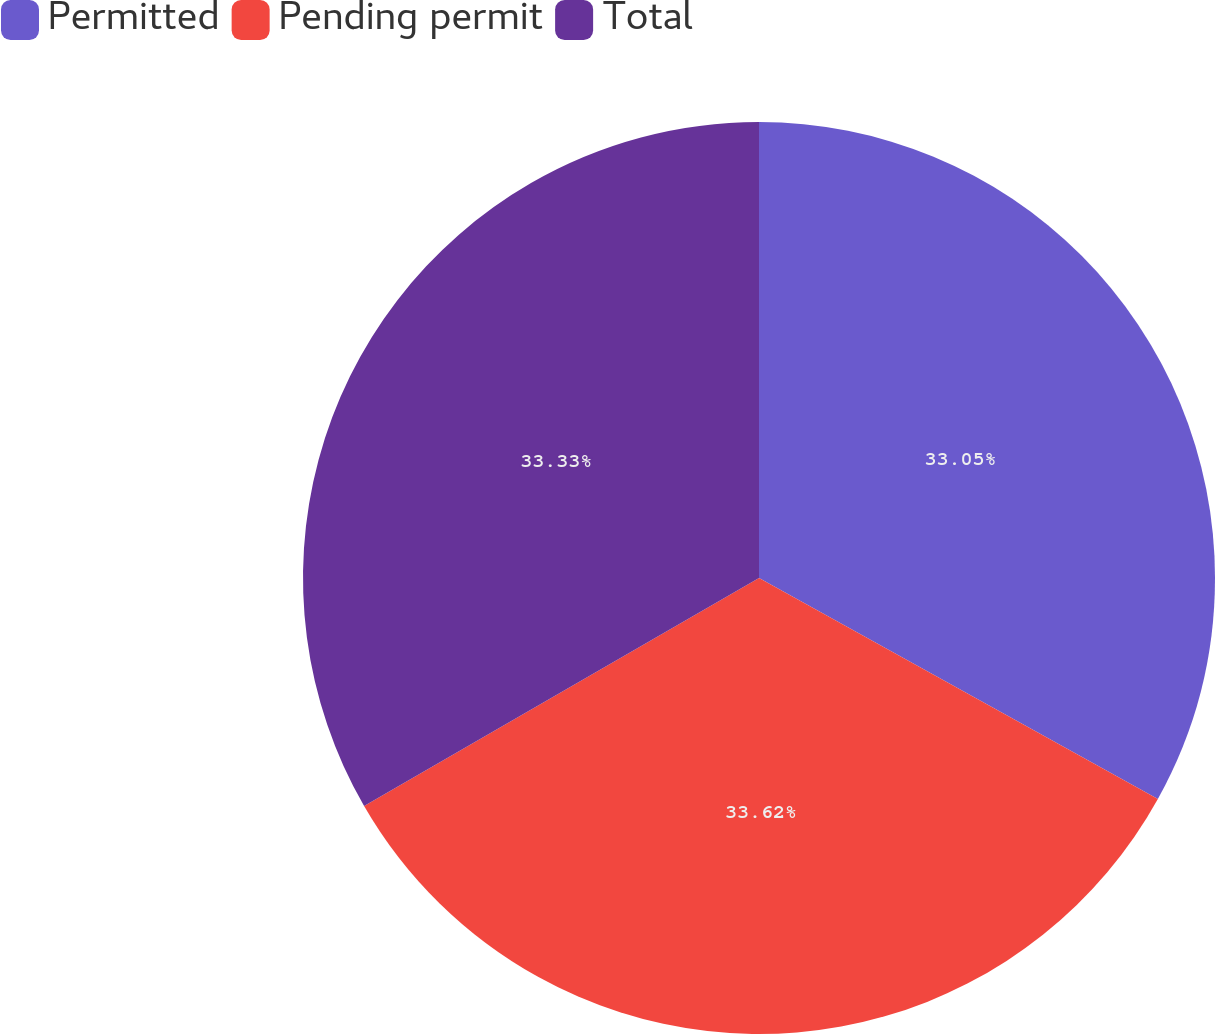Convert chart to OTSL. <chart><loc_0><loc_0><loc_500><loc_500><pie_chart><fcel>Permitted<fcel>Pending permit<fcel>Total<nl><fcel>33.05%<fcel>33.61%<fcel>33.33%<nl></chart> 